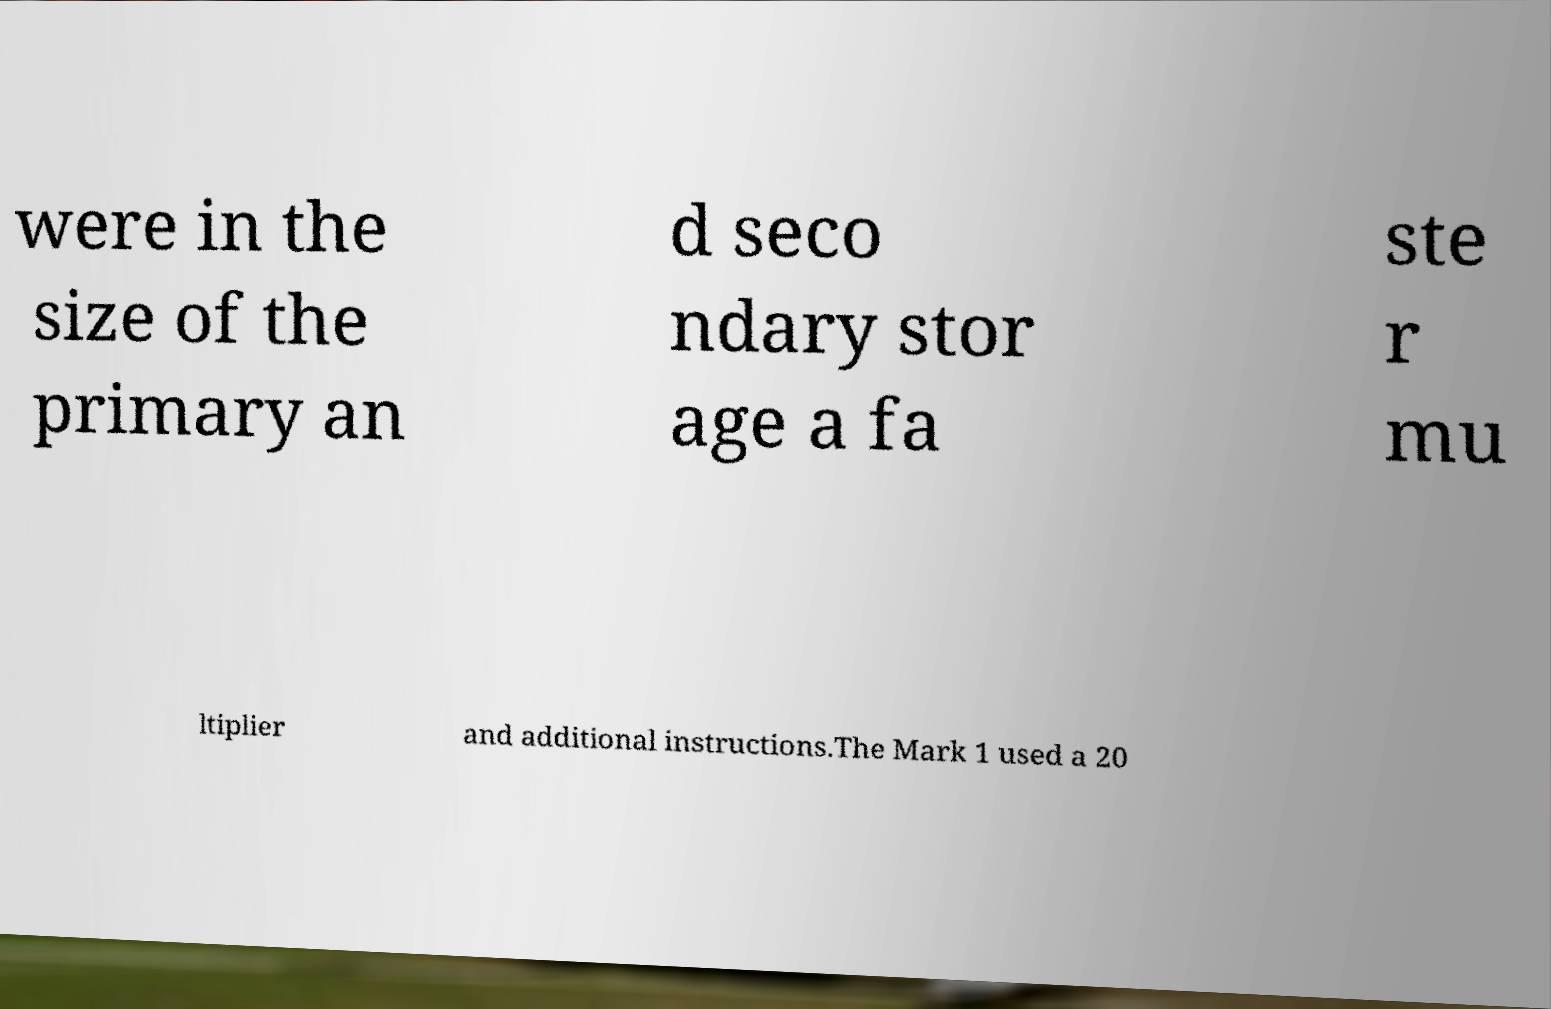What messages or text are displayed in this image? I need them in a readable, typed format. were in the size of the primary an d seco ndary stor age a fa ste r mu ltiplier and additional instructions.The Mark 1 used a 20 